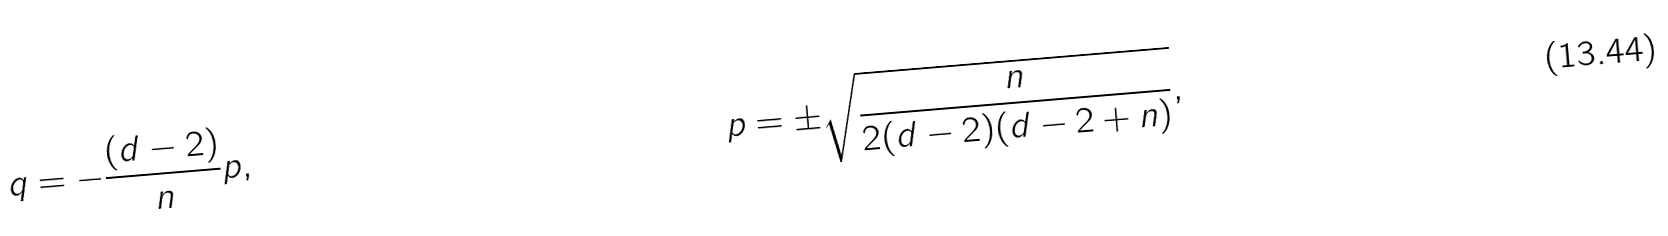Convert formula to latex. <formula><loc_0><loc_0><loc_500><loc_500>q & = - \frac { ( d - 2 ) } { n } p , & p & = \pm \sqrt { \frac { n } { 2 ( d - 2 ) ( d - 2 + n ) } } ,</formula> 